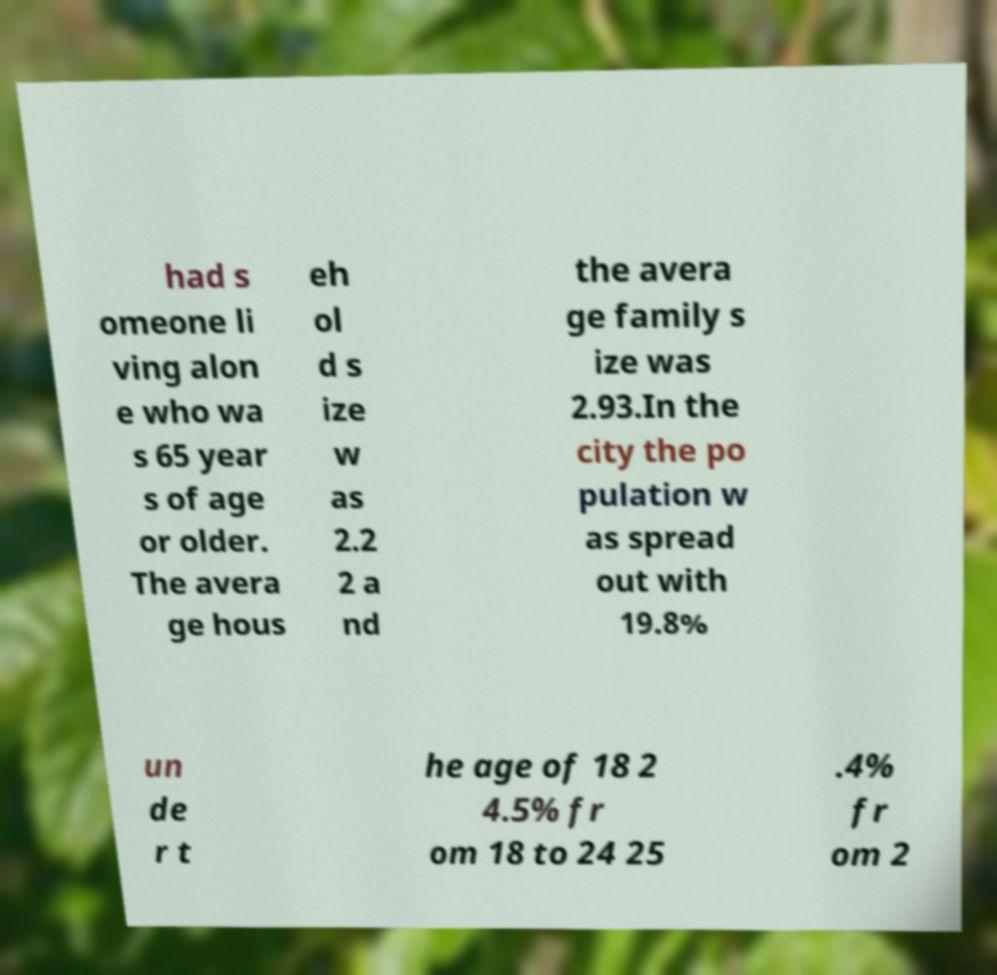There's text embedded in this image that I need extracted. Can you transcribe it verbatim? had s omeone li ving alon e who wa s 65 year s of age or older. The avera ge hous eh ol d s ize w as 2.2 2 a nd the avera ge family s ize was 2.93.In the city the po pulation w as spread out with 19.8% un de r t he age of 18 2 4.5% fr om 18 to 24 25 .4% fr om 2 